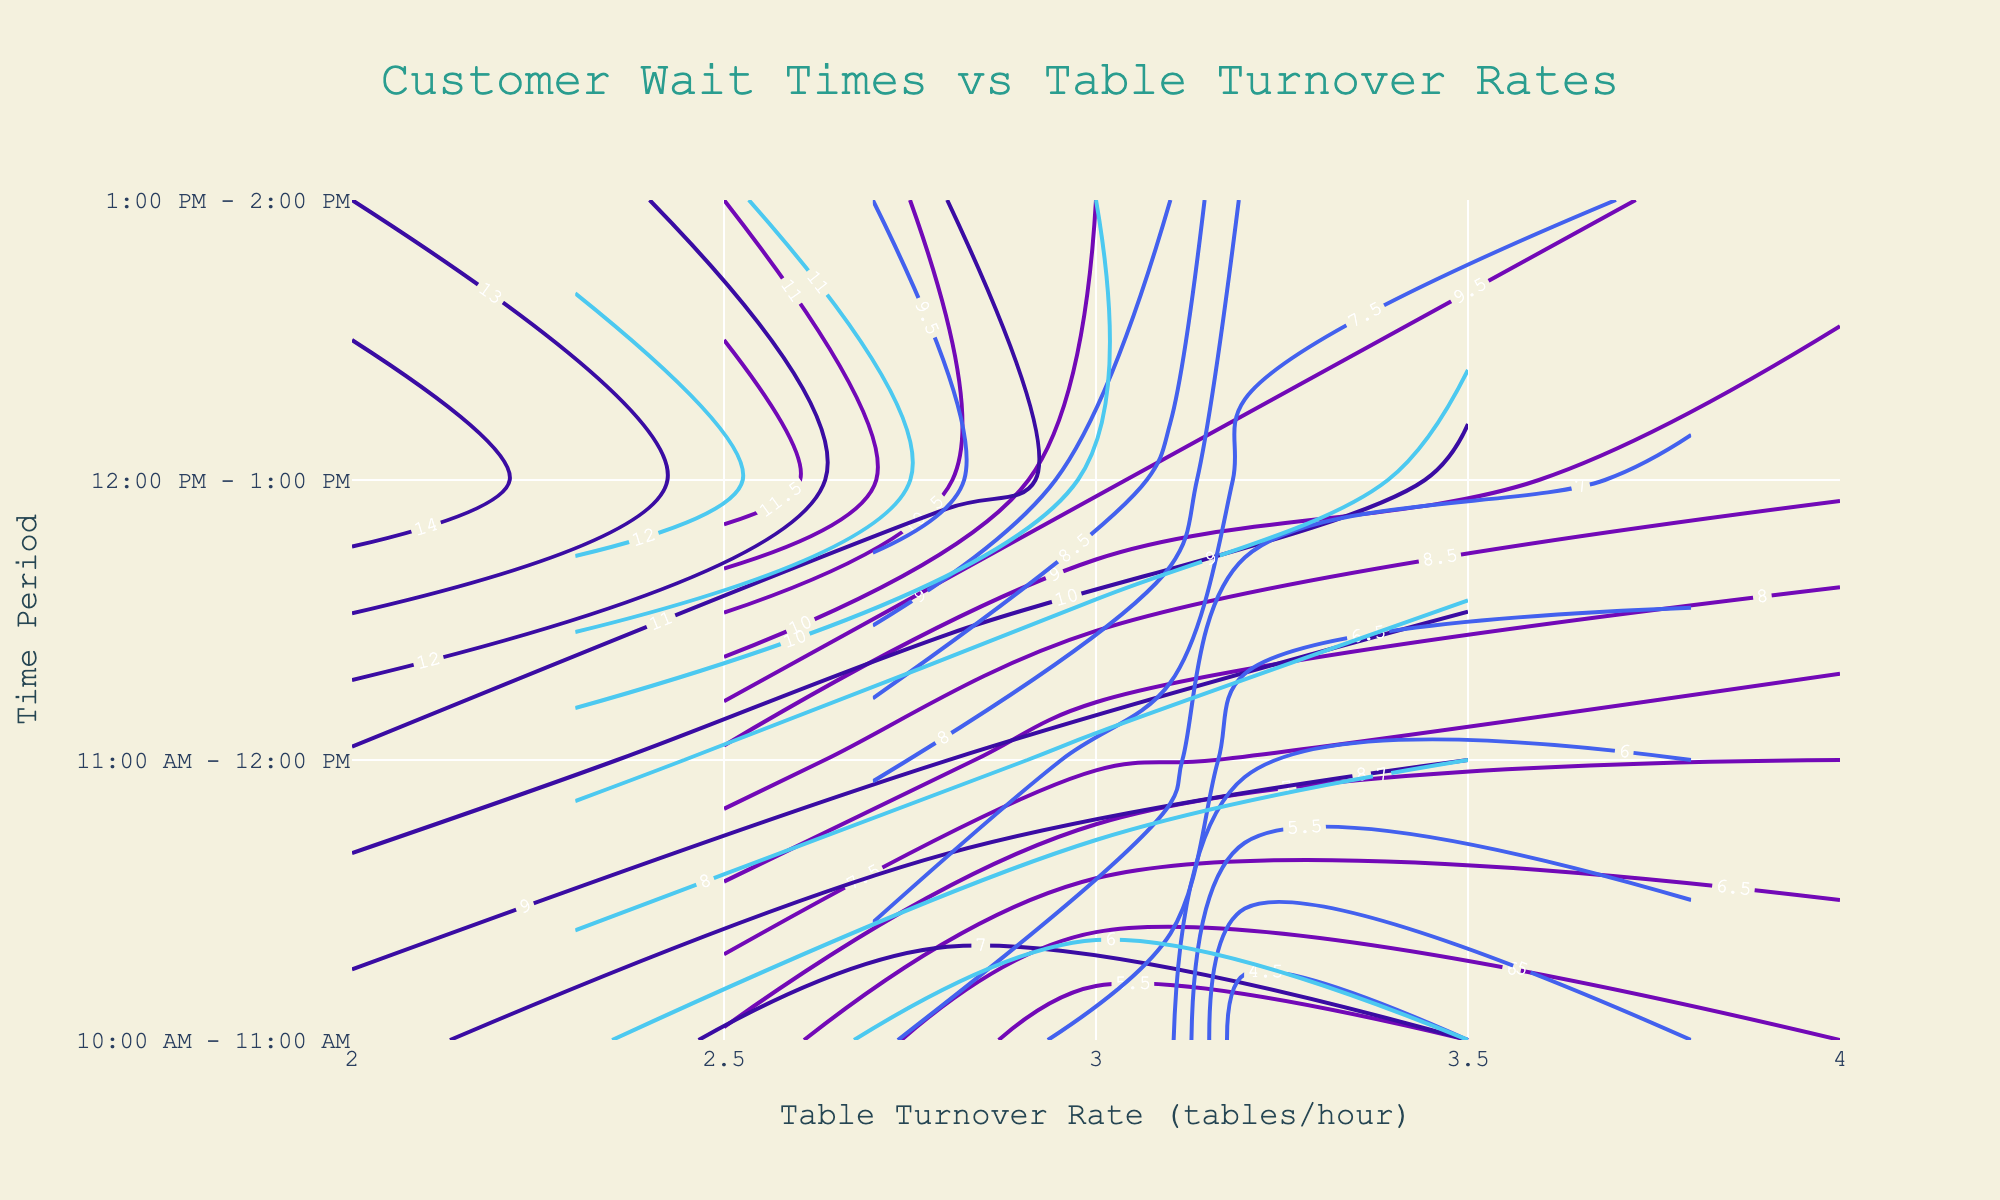What is the title of the plot? The title of the plot is typically located at the top center of a figure. Here, it reads "Customer Wait Times vs Table Turnover Rates".
Answer: Customer Wait Times vs Table Turnover Rates What is the y-axis label on the plot? To find the y-axis label, look at the vertical axis on the left-hand side of the plot. It is labeled "Time Period".
Answer: Time Period Which restaurant has the highest customer wait time around noon? To answer this, look at the contour lines for all restaurants around the 11:00 AM - 12:00 PM timeframe and compare the wait times. "The Grape Escape" has the highest wait time with 15 minutes.
Answer: The Grape Escape How does the table turnover rate at "Vineyard Delight" compare between the time periods 11:00 AM - 12:00 PM and 12:00 PM - 1:00 PM? Compare the table turnover rates for "Vineyard Delight" at these time periods by looking at the x-axis values corresponding to these times. The rates are 4 tables/hour and 2.5 tables/hour respectively, indicating a decrease.
Answer: The rate is higher from 11:00 AM - 12:00 PM than from 12:00 PM - 1:00 PM What is the range of customer wait times during lunch hours (12:00 PM - 1:00 PM) across all restaurants? To find this, observe the contours for all restaurants between 12:00 PM and 1:00 PM. The wait times range from 10 minutes to 15 minutes across all restaurants.
Answer: 10 to 15 minutes Which restaurant has the lowest table turnover rate in the earliest time slot (10:00 AM - 11:00 AM)? Check the x-axis values for each restaurant at 10:00 AM - 11:00 AM. "The Grape Escape" has the lowest rate at 2.8 tables/hour.
Answer: The Grape Escape Is there a general trend between customer wait times and table turnover rates across all restaurants? Analyze the contour lines on the plot. As table turnover rates increase (right direction on x-axis), customer wait times tend to decrease (lower z-values in colors). This suggests an inverse relationship.
Answer: Wait times generally decrease as turnover rates increase Which restaurant shows the most noticeable change in customer wait times between the periods 11:00 AM - 12:00 PM and 12:00 PM - 1:00 PM? Compare the wait times for each restaurant between these periods. "The Grape Escape" shows the most noticeable change, increasing from 8 minutes to 15 minutes.
Answer: The Grape Escape 